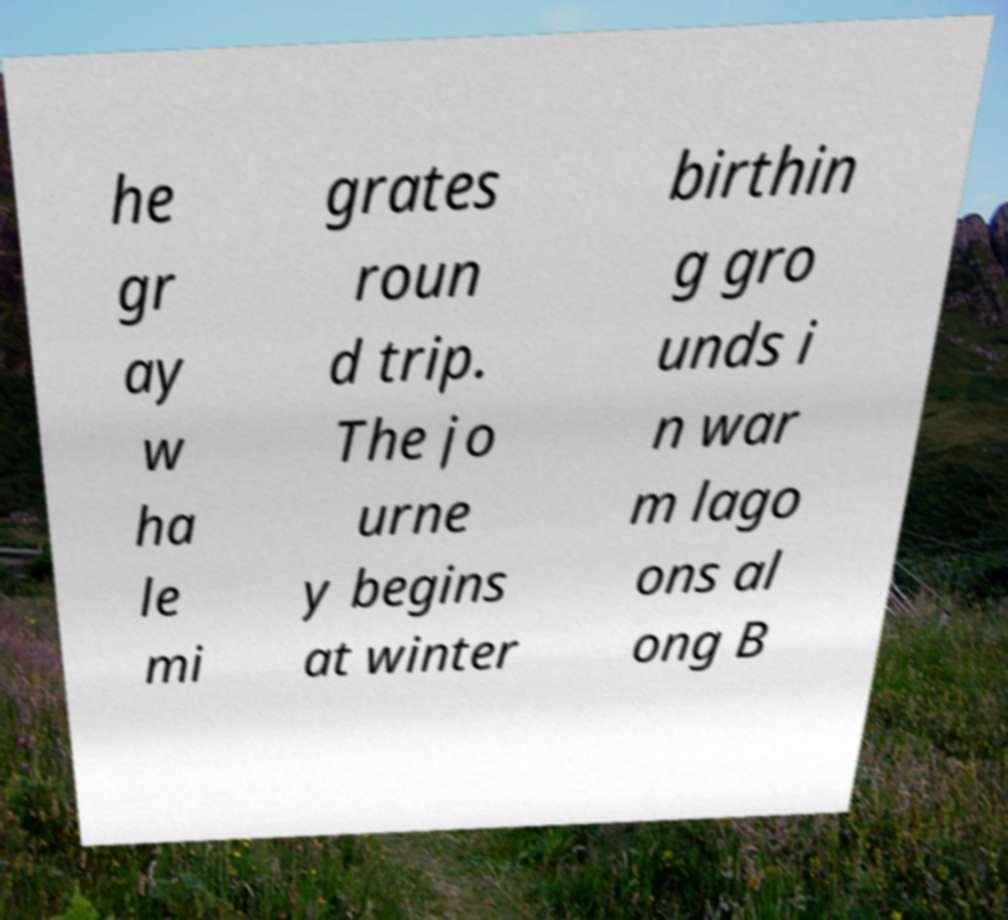Please read and relay the text visible in this image. What does it say? he gr ay w ha le mi grates roun d trip. The jo urne y begins at winter birthin g gro unds i n war m lago ons al ong B 